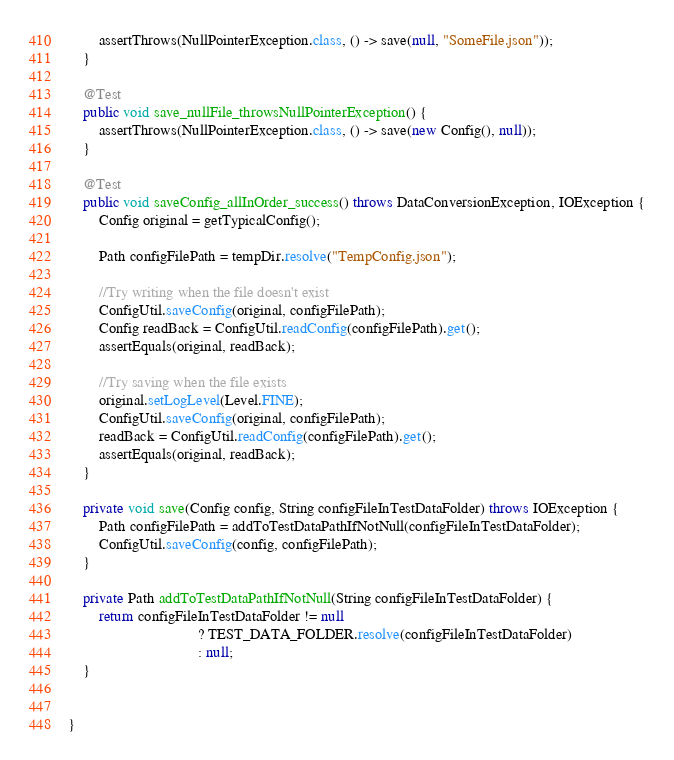Convert code to text. <code><loc_0><loc_0><loc_500><loc_500><_Java_>        assertThrows(NullPointerException.class, () -> save(null, "SomeFile.json"));
    }

    @Test
    public void save_nullFile_throwsNullPointerException() {
        assertThrows(NullPointerException.class, () -> save(new Config(), null));
    }

    @Test
    public void saveConfig_allInOrder_success() throws DataConversionException, IOException {
        Config original = getTypicalConfig();

        Path configFilePath = tempDir.resolve("TempConfig.json");

        //Try writing when the file doesn't exist
        ConfigUtil.saveConfig(original, configFilePath);
        Config readBack = ConfigUtil.readConfig(configFilePath).get();
        assertEquals(original, readBack);

        //Try saving when the file exists
        original.setLogLevel(Level.FINE);
        ConfigUtil.saveConfig(original, configFilePath);
        readBack = ConfigUtil.readConfig(configFilePath).get();
        assertEquals(original, readBack);
    }

    private void save(Config config, String configFileInTestDataFolder) throws IOException {
        Path configFilePath = addToTestDataPathIfNotNull(configFileInTestDataFolder);
        ConfigUtil.saveConfig(config, configFilePath);
    }

    private Path addToTestDataPathIfNotNull(String configFileInTestDataFolder) {
        return configFileInTestDataFolder != null
                                  ? TEST_DATA_FOLDER.resolve(configFileInTestDataFolder)
                                  : null;
    }


}
</code> 